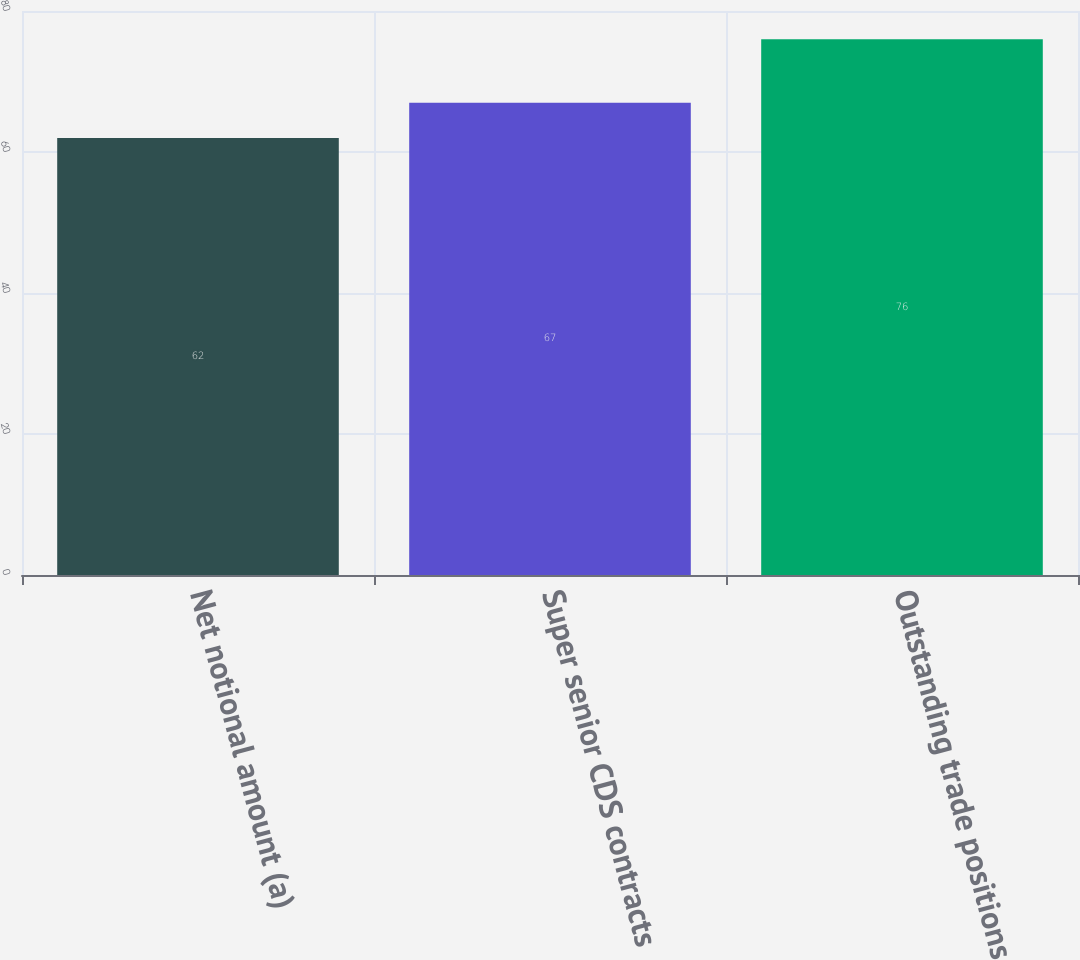Convert chart. <chart><loc_0><loc_0><loc_500><loc_500><bar_chart><fcel>Net notional amount (a)<fcel>Super senior CDS contracts<fcel>Outstanding trade positions<nl><fcel>62<fcel>67<fcel>76<nl></chart> 